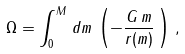Convert formula to latex. <formula><loc_0><loc_0><loc_500><loc_500>\Omega = \int _ { 0 } ^ { M } \, d m \, \left ( - \frac { G \, m } { r ( m ) } \, \right ) \, ,</formula> 